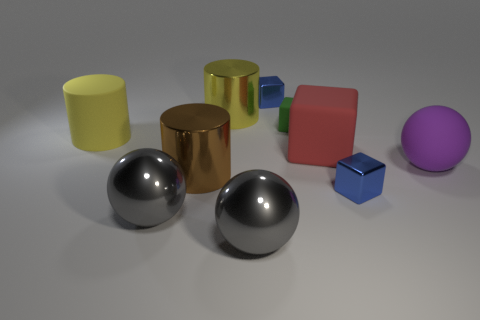Subtract all tiny matte blocks. How many blocks are left? 3 Subtract 1 blocks. How many blocks are left? 3 Subtract all yellow balls. How many brown cubes are left? 0 Subtract all yellow cylinders. How many cylinders are left? 1 Subtract 0 gray blocks. How many objects are left? 10 Subtract all balls. How many objects are left? 7 Subtract all yellow blocks. Subtract all green cylinders. How many blocks are left? 4 Subtract all big yellow metallic things. Subtract all yellow matte cylinders. How many objects are left? 8 Add 6 large yellow shiny objects. How many large yellow shiny objects are left? 7 Add 2 large brown metal things. How many large brown metal things exist? 3 